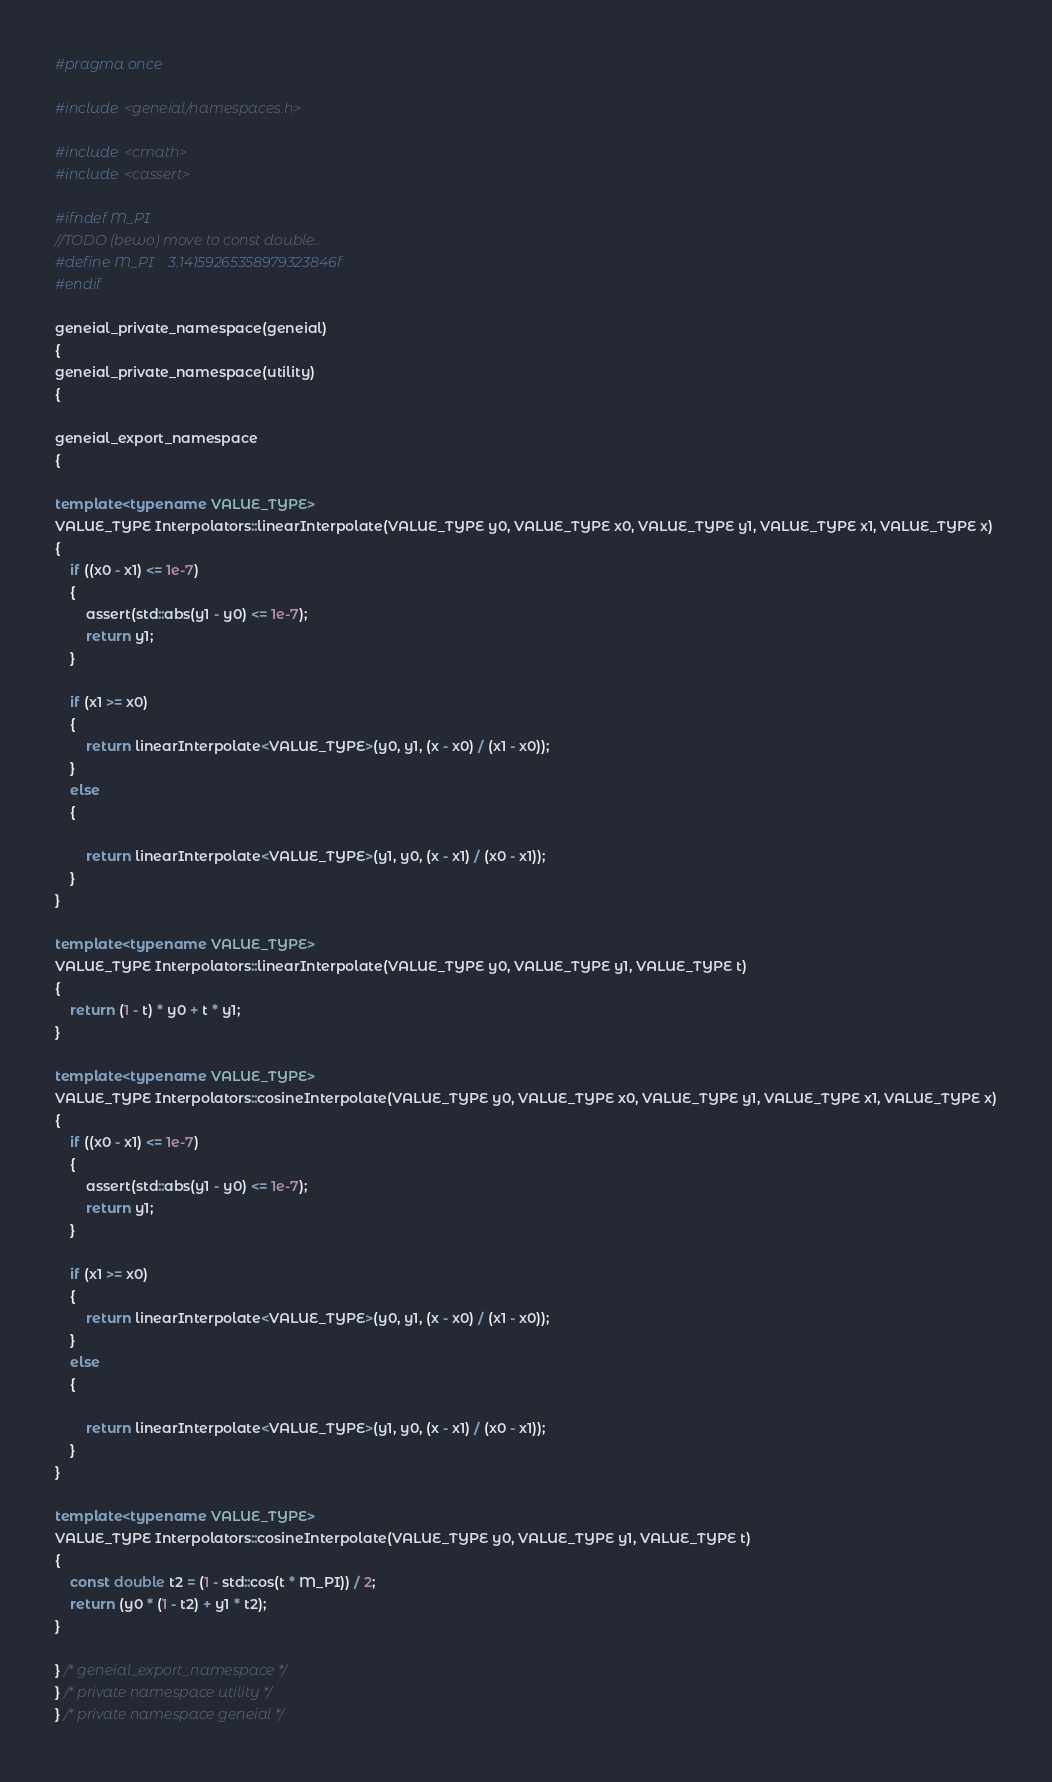Convert code to text. <code><loc_0><loc_0><loc_500><loc_500><_C++_>#pragma once

#include <geneial/namespaces.h>

#include <cmath>
#include <cassert>

#ifndef M_PI
//TODO (bewo) move to const double..
#define M_PI    3.14159265358979323846f
#endif

geneial_private_namespace(geneial)
{
geneial_private_namespace(utility)
{

geneial_export_namespace
{

template<typename VALUE_TYPE>
VALUE_TYPE Interpolators::linearInterpolate(VALUE_TYPE y0, VALUE_TYPE x0, VALUE_TYPE y1, VALUE_TYPE x1, VALUE_TYPE x)
{
    if ((x0 - x1) <= 1e-7)
    {
        assert(std::abs(y1 - y0) <= 1e-7);
        return y1;
    }

    if (x1 >= x0)
    {
        return linearInterpolate<VALUE_TYPE>(y0, y1, (x - x0) / (x1 - x0));
    }
    else
    {

        return linearInterpolate<VALUE_TYPE>(y1, y0, (x - x1) / (x0 - x1));
    }
}

template<typename VALUE_TYPE>
VALUE_TYPE Interpolators::linearInterpolate(VALUE_TYPE y0, VALUE_TYPE y1, VALUE_TYPE t)
{
    return (1 - t) * y0 + t * y1;
}

template<typename VALUE_TYPE>
VALUE_TYPE Interpolators::cosineInterpolate(VALUE_TYPE y0, VALUE_TYPE x0, VALUE_TYPE y1, VALUE_TYPE x1, VALUE_TYPE x)
{
    if ((x0 - x1) <= 1e-7)
    {
        assert(std::abs(y1 - y0) <= 1e-7);
        return y1;
    }

    if (x1 >= x0)
    {
        return linearInterpolate<VALUE_TYPE>(y0, y1, (x - x0) / (x1 - x0));
    }
    else
    {

        return linearInterpolate<VALUE_TYPE>(y1, y0, (x - x1) / (x0 - x1));
    }
}

template<typename VALUE_TYPE>
VALUE_TYPE Interpolators::cosineInterpolate(VALUE_TYPE y0, VALUE_TYPE y1, VALUE_TYPE t)
{
    const double t2 = (1 - std::cos(t * M_PI)) / 2;
    return (y0 * (1 - t2) + y1 * t2);
}

} /* geneial_export_namespace */
} /* private namespace utility */
} /* private namespace geneial */

</code> 